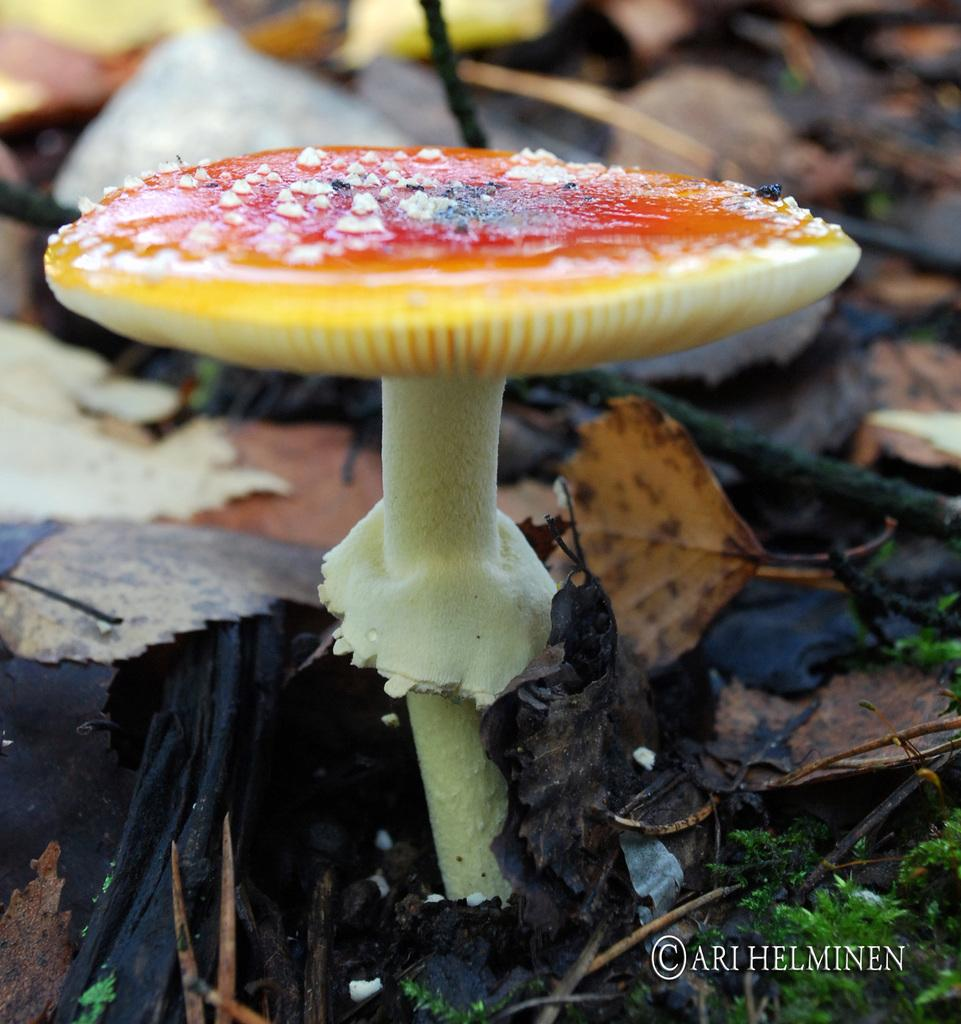What is the main subject of the image? There is a mushroom in the middle of the image. Is there any text or logo visible in the image? Yes, there is a watermark in the bottom right corner of the image. What type of vegetation can be seen in the background of the image? Dried leaves are present in the background of the image. How many brothers are shown playing with the mushroom in the image? There are no people, including brothers, present in the image; it only features a mushroom and dried leaves in the background. 